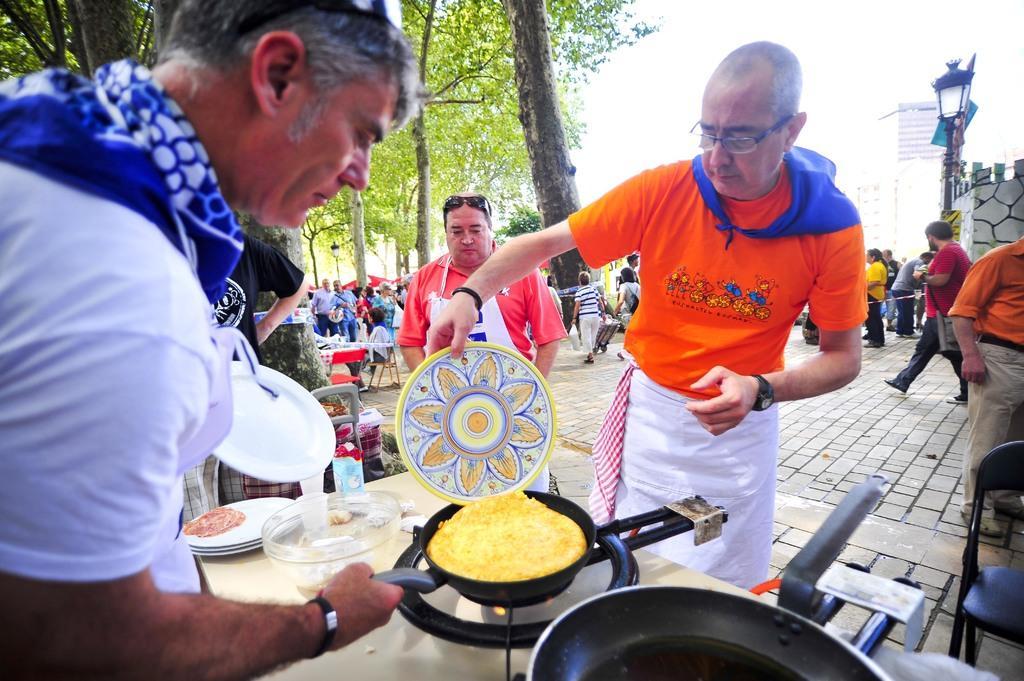Could you give a brief overview of what you see in this image? In this image I can see a person standing beside the table and cooking food on the stove, beside him there are so many people standing also there are few trees. 